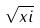<formula> <loc_0><loc_0><loc_500><loc_500>\sqrt { x i }</formula> 